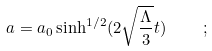Convert formula to latex. <formula><loc_0><loc_0><loc_500><loc_500>a = a _ { 0 } \sinh ^ { 1 / 2 } ( 2 \sqrt { \frac { \Lambda } { 3 } } t ) \quad ;</formula> 